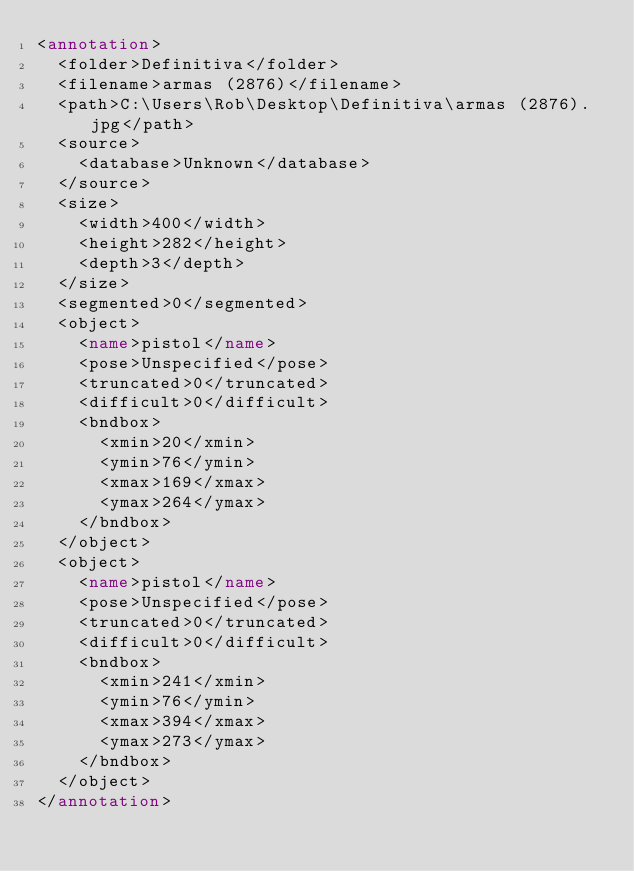Convert code to text. <code><loc_0><loc_0><loc_500><loc_500><_XML_><annotation>
  <folder>Definitiva</folder>
  <filename>armas (2876)</filename>
  <path>C:\Users\Rob\Desktop\Definitiva\armas (2876).jpg</path>
  <source>
    <database>Unknown</database>
  </source>
  <size>
    <width>400</width>
    <height>282</height>
    <depth>3</depth>
  </size>
  <segmented>0</segmented>
  <object>
    <name>pistol</name>
    <pose>Unspecified</pose>
    <truncated>0</truncated>
    <difficult>0</difficult>
    <bndbox>
      <xmin>20</xmin>
      <ymin>76</ymin>
      <xmax>169</xmax>
      <ymax>264</ymax>
    </bndbox>
  </object>
  <object>
    <name>pistol</name>
    <pose>Unspecified</pose>
    <truncated>0</truncated>
    <difficult>0</difficult>
    <bndbox>
      <xmin>241</xmin>
      <ymin>76</ymin>
      <xmax>394</xmax>
      <ymax>273</ymax>
    </bndbox>
  </object>
</annotation>
</code> 